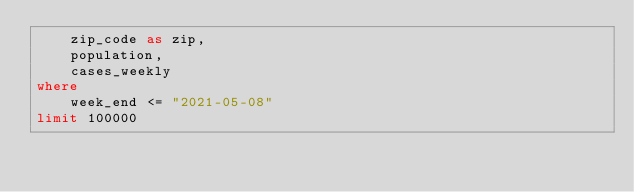<code> <loc_0><loc_0><loc_500><loc_500><_SQL_>    zip_code as zip,
    population,
    cases_weekly
where
    week_end <= "2021-05-08"
limit 100000</code> 